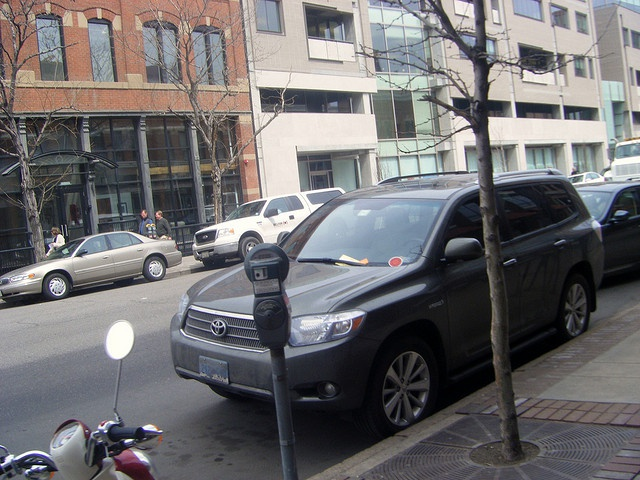Describe the objects in this image and their specific colors. I can see car in brown, black, darkgray, and gray tones, motorcycle in brown, gray, black, white, and darkgray tones, car in brown, darkgray, lightgray, gray, and black tones, car in brown, white, darkgray, gray, and black tones, and car in brown, black, darkgray, gray, and lightgray tones in this image. 